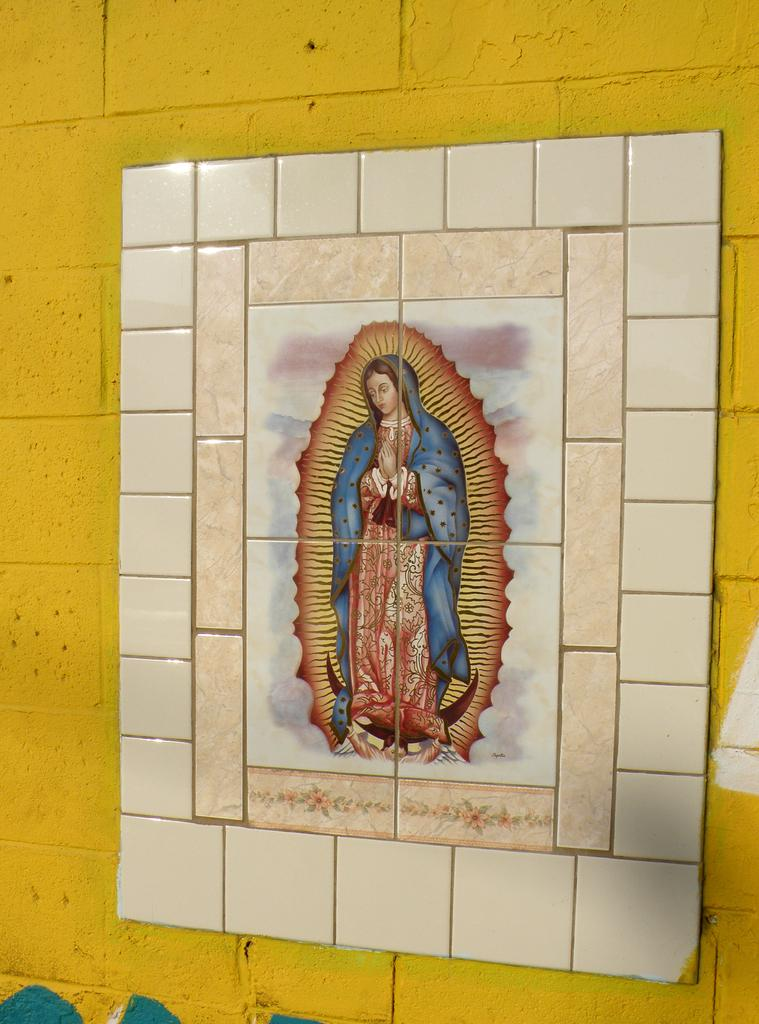How are the individual tiles related in the image? The image consists of four tiles combined to form a picture. What is the subject of the combined image? The combined image forms a picture of a woman. What is the color of the wall in the image? The wall is in yellow color. How many children are playing with the girl in the image? There are no children or girl present in the image; it features a picture of a woman. What type of curtain is hanging near the woman in the image? There is no curtain present in the image; it only shows a woman and a yellow wall. 